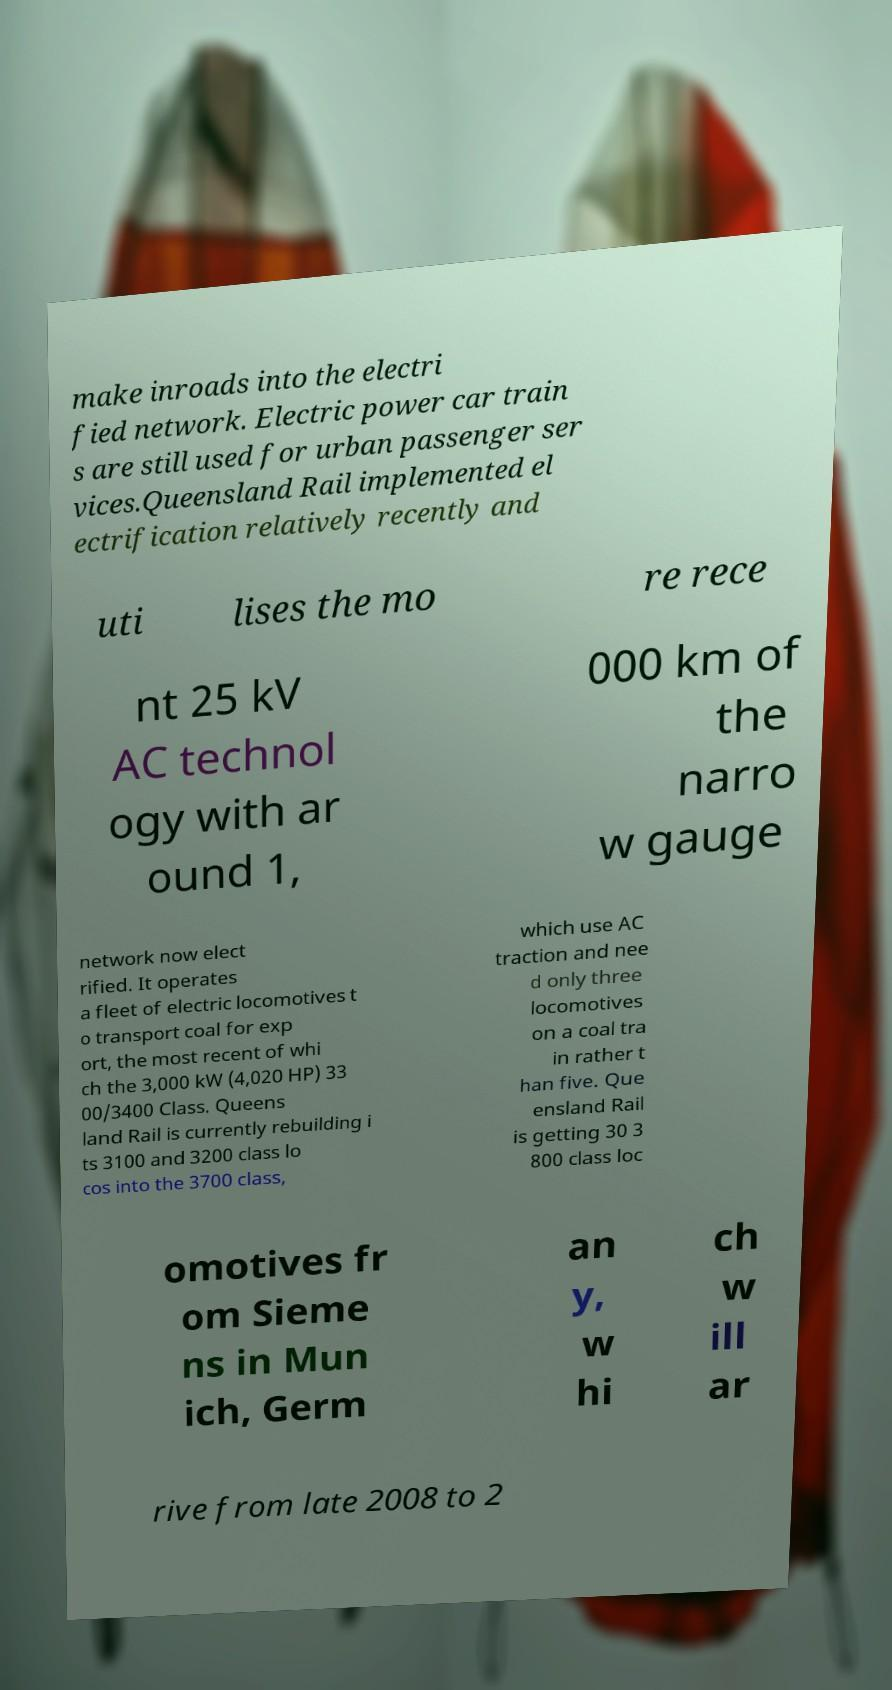I need the written content from this picture converted into text. Can you do that? make inroads into the electri fied network. Electric power car train s are still used for urban passenger ser vices.Queensland Rail implemented el ectrification relatively recently and uti lises the mo re rece nt 25 kV AC technol ogy with ar ound 1, 000 km of the narro w gauge network now elect rified. It operates a fleet of electric locomotives t o transport coal for exp ort, the most recent of whi ch the 3,000 kW (4,020 HP) 33 00/3400 Class. Queens land Rail is currently rebuilding i ts 3100 and 3200 class lo cos into the 3700 class, which use AC traction and nee d only three locomotives on a coal tra in rather t han five. Que ensland Rail is getting 30 3 800 class loc omotives fr om Sieme ns in Mun ich, Germ an y, w hi ch w ill ar rive from late 2008 to 2 